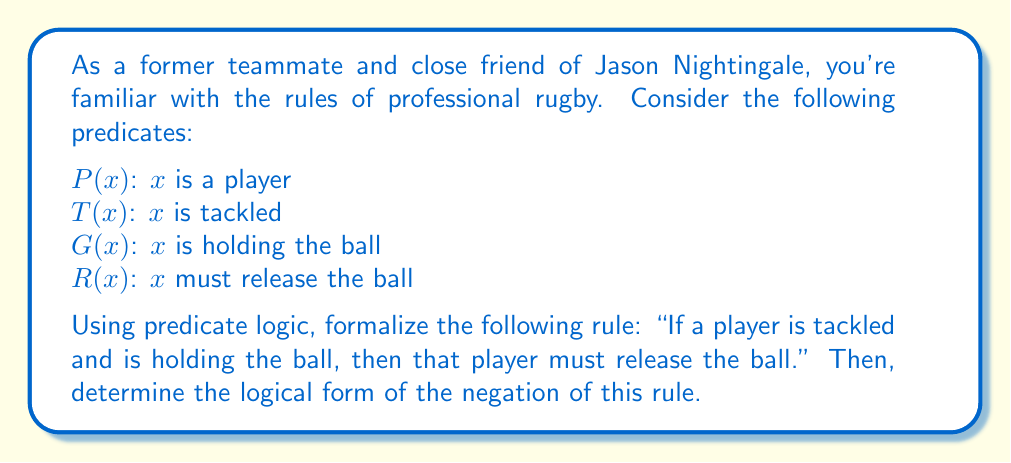Show me your answer to this math problem. Let's approach this step-by-step:

1) First, we need to formalize the given rule using predicate logic. The rule can be broken down into three parts:
   - $x$ is a player
   - $x$ is tackled and is holding the ball
   - $x$ must release the ball

2) We can express this rule as:
   $$\forall x [(P(x) \land T(x) \land G(x)) \rightarrow R(x)]$$

   This reads as: "For all $x$, if $x$ is a player and $x$ is tackled and $x$ is holding the ball, then $x$ must release the ball."

3) To find the negation of this rule, we need to apply the negation operation to the entire statement. The negation of an implication $A \rightarrow B$ is $A \land \lnot B$, and the negation of a universal quantifier $\forall$ is an existential quantifier $\exists$.

4) Applying these principles, the negation becomes:
   $$\exists x [(P(x) \land T(x) \land G(x)) \land \lnot R(x)]$$

5) This negation can be read as: "There exists an $x$ such that $x$ is a player and $x$ is tackled and $x$ is holding the ball, but $x$ does not release the ball."

This negation essentially describes a situation where the rule is violated, which could result in a penalty in a real rugby game.
Answer: The negation of the rule in predicate logic is:
$$\exists x [(P(x) \land T(x) \land G(x)) \land \lnot R(x)]$$ 